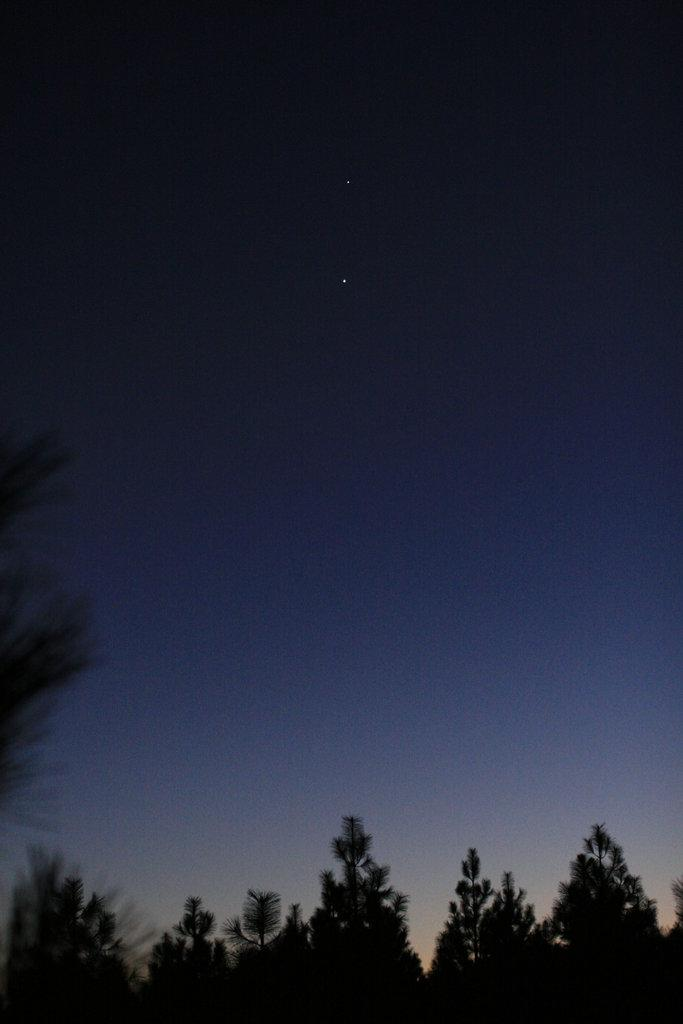What is the overall lighting condition of the image? The image is dark. What type of vegetation can be seen in the image? There are trees in the image. What part of the natural environment is visible in the image? The sky is visible in the image. How many apples are hanging from the trees in the image? There are no apples visible in the image; only trees and the sky can be seen. What type of connection is established between the trees in the image? There is no connection established between the trees in the image; the image simply shows trees and the sky. 